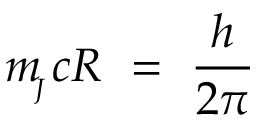<formula> <loc_0><loc_0><loc_500><loc_500>m _ { \, _ { J } } c R \ = \ \frac { h } { 2 \pi }</formula> 